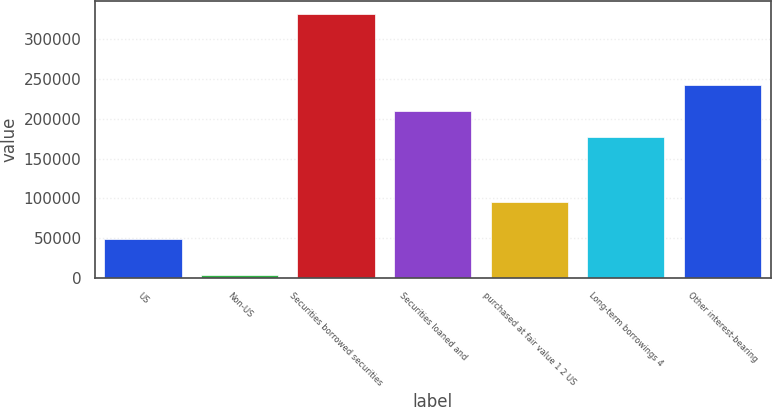Convert chart. <chart><loc_0><loc_0><loc_500><loc_500><bar_chart><fcel>US<fcel>Non-US<fcel>Securities borrowed securities<fcel>Securities loaned and<fcel>purchased at fair value 1 2 US<fcel>Long-term borrowings 4<fcel>Other interest-bearing<nl><fcel>49123<fcel>3377<fcel>331828<fcel>209543<fcel>94740<fcel>176698<fcel>242388<nl></chart> 